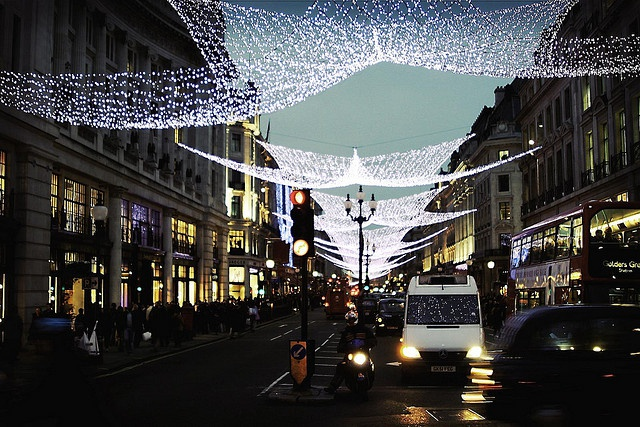Describe the objects in this image and their specific colors. I can see bus in black, gray, ivory, and olive tones, car in black, gray, and ivory tones, truck in black, darkgray, gray, and ivory tones, car in black, darkgray, gray, and ivory tones, and traffic light in black, ivory, khaki, and red tones in this image. 